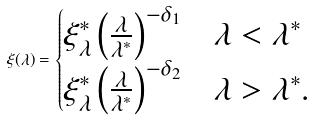<formula> <loc_0><loc_0><loc_500><loc_500>\xi ( \lambda ) = \begin{cases} \xi ^ { * } _ { \lambda } \left ( \frac { \lambda } { \lambda ^ { * } } \right ) ^ { - \delta _ { 1 } } & \lambda < \lambda ^ { * } \\ \xi ^ { * } _ { \lambda } \left ( \frac { \lambda } { \lambda ^ { * } } \right ) ^ { - \delta _ { 2 } } & \lambda > \lambda ^ { * } . \end{cases}</formula> 